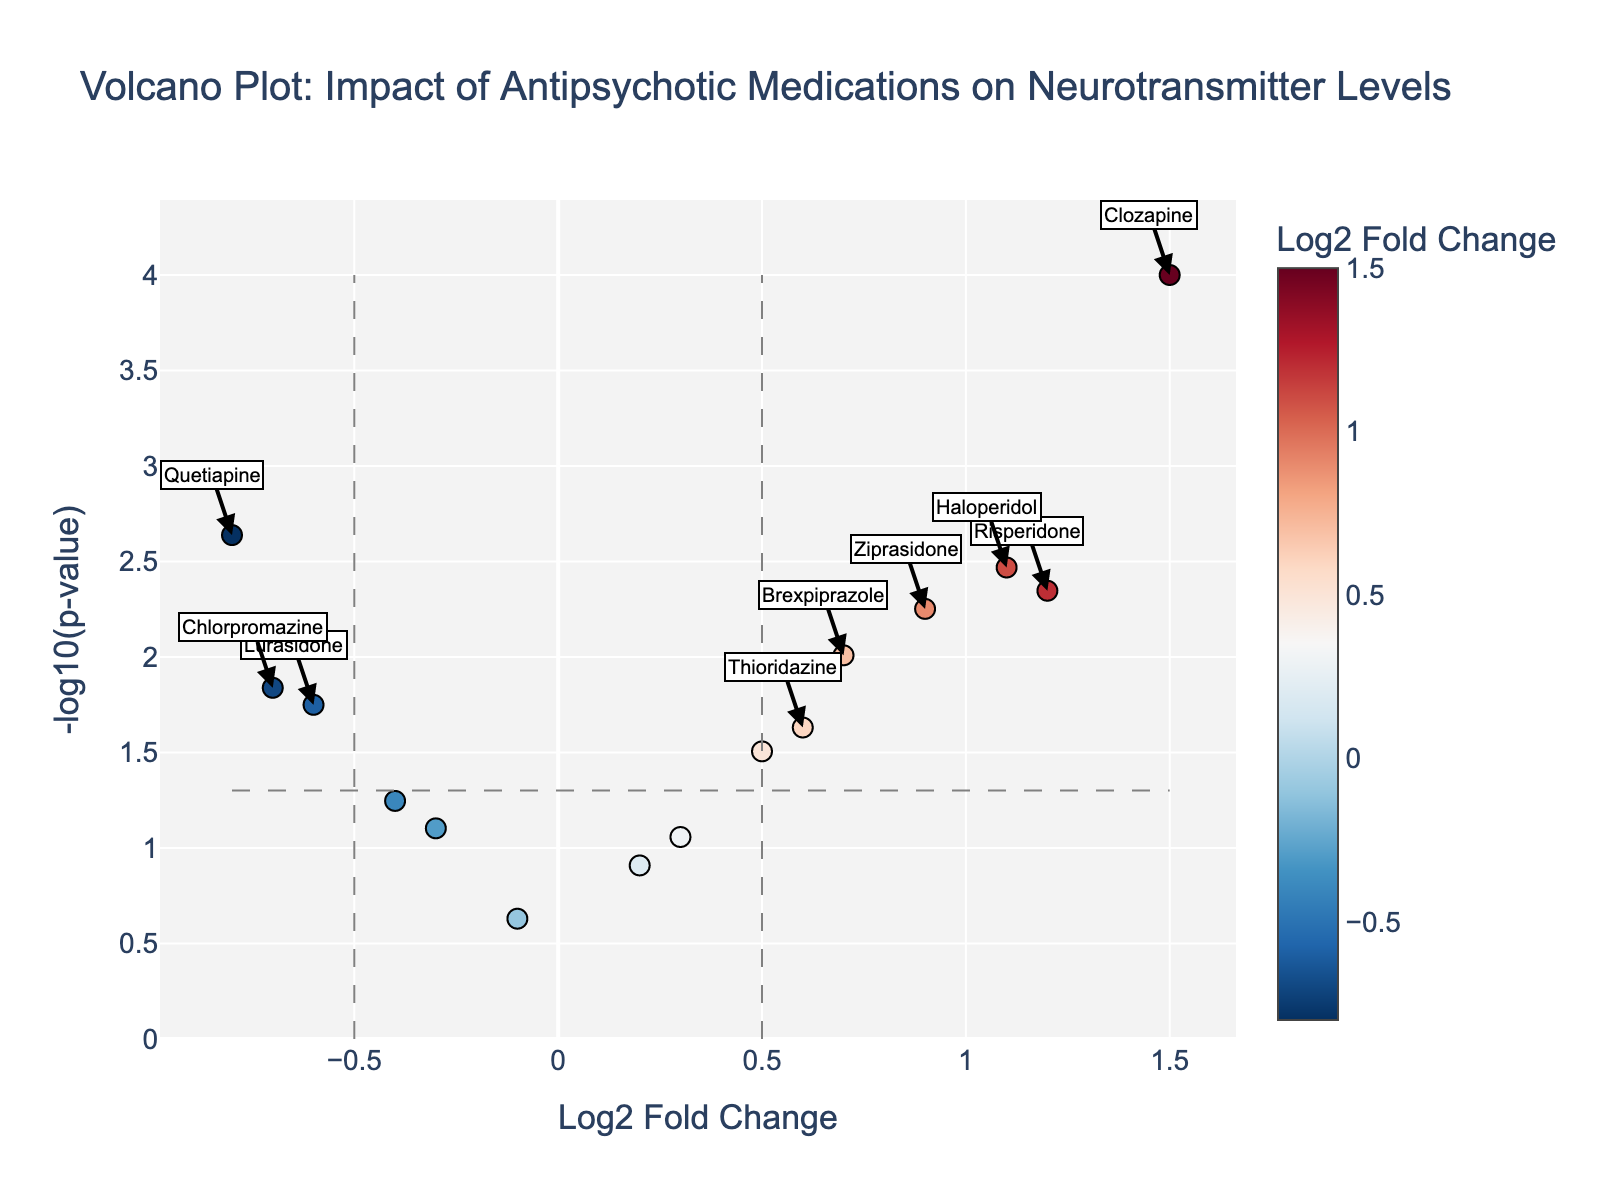What is the title of the plot? The title is prominently displayed at the top of the plot and reads "Volcano Plot: Impact of Antipsychotic Medications on Neurotransmitter Levels".
Answer: Volcano Plot: Impact of Antipsychotic Medications on Neurotransmitter Levels What are the axes labels in the plot? The x-axis is labeled "Log2 Fold Change" and the y-axis is labeled "-log10(p-value)".
Answer: Log2 Fold Change and -log10(p-value) How many drugs have a negative Log2 Fold Change? Count the data points that are to the left of the y-axis (log2 fold change < 0).
Answer: 6 Which drug shows the highest impact (Log2 Fold Change) and its corresponding p-value? Identify the data point farthest to the right on the x-axis and check its hover text.
Answer: Clozapine, p-value: 0.0001 Which drugs are considered statistically significant based on the plot's thresholds? Look for data points that fall outside the area defined by the threshold lines, both on the left and right sides.
Answer: Clozapine, Haloperidol, Risperidone, Quetiapine, Ziprasidone, Brexpiprazole, and Lurasidone What is the general color gradient used in the plot, and what does it represent? Refer to the color bar on the right side of the plot. It ranges from blue to red, representing different values of Log2 Fold Change.
Answer: Red to blue, representing Log2 Fold Change Which drug has the lowest p-value? Locate the data point that is highest on the y-axis, indicating the highest -log10(p-value). Check its hover text.
Answer: Clozapine Are there any drugs with Log2 Fold Change close to zero, and if yes, what are they? Identify the data points that are near the center on the x-axis (Log2 Fold Change ≈ 0).
Answer: Paliperidone, Aripiprazole, Cariprazine According to the plot, which drug shows the largest positive Log2 Fold Change but is not statistically significant? Look for the drug with the highest positive Log2 Fold Change that does not cross the p-value threshold line.
Answer: Iloperidone What does the horizontal dashed line represent in the plot? This line indicates the p-value threshold for statistical significance; above this line, the p-values are less than 0.05.
Answer: p-value threshold 